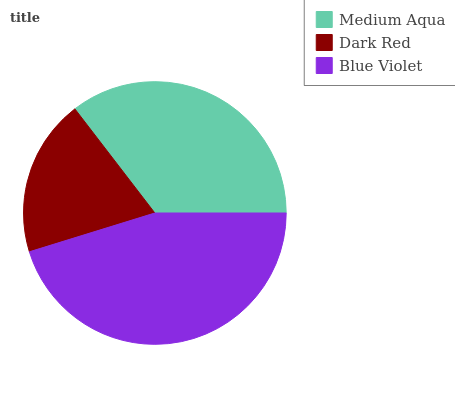Is Dark Red the minimum?
Answer yes or no. Yes. Is Blue Violet the maximum?
Answer yes or no. Yes. Is Blue Violet the minimum?
Answer yes or no. No. Is Dark Red the maximum?
Answer yes or no. No. Is Blue Violet greater than Dark Red?
Answer yes or no. Yes. Is Dark Red less than Blue Violet?
Answer yes or no. Yes. Is Dark Red greater than Blue Violet?
Answer yes or no. No. Is Blue Violet less than Dark Red?
Answer yes or no. No. Is Medium Aqua the high median?
Answer yes or no. Yes. Is Medium Aqua the low median?
Answer yes or no. Yes. Is Blue Violet the high median?
Answer yes or no. No. Is Blue Violet the low median?
Answer yes or no. No. 